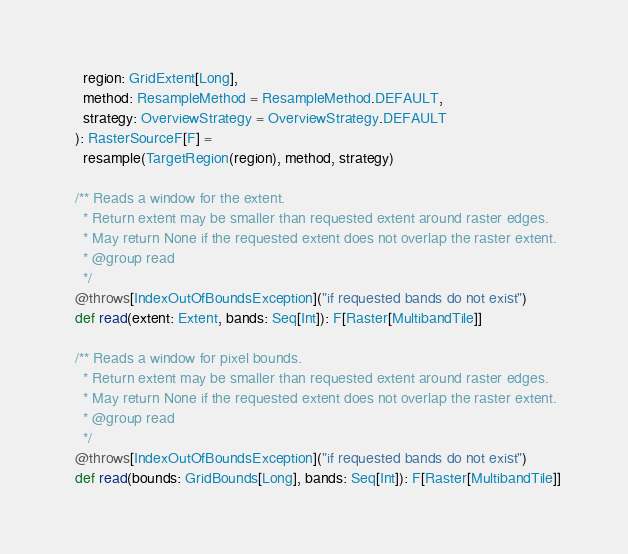Convert code to text. <code><loc_0><loc_0><loc_500><loc_500><_Scala_>    region: GridExtent[Long],
    method: ResampleMethod = ResampleMethod.DEFAULT,
    strategy: OverviewStrategy = OverviewStrategy.DEFAULT
  ): RasterSourceF[F] =
    resample(TargetRegion(region), method, strategy)

  /** Reads a window for the extent.
    * Return extent may be smaller than requested extent around raster edges.
    * May return None if the requested extent does not overlap the raster extent.
    * @group read
    */
  @throws[IndexOutOfBoundsException]("if requested bands do not exist")
  def read(extent: Extent, bands: Seq[Int]): F[Raster[MultibandTile]]

  /** Reads a window for pixel bounds.
    * Return extent may be smaller than requested extent around raster edges.
    * May return None if the requested extent does not overlap the raster extent.
    * @group read
    */
  @throws[IndexOutOfBoundsException]("if requested bands do not exist")
  def read(bounds: GridBounds[Long], bands: Seq[Int]): F[Raster[MultibandTile]]
</code> 